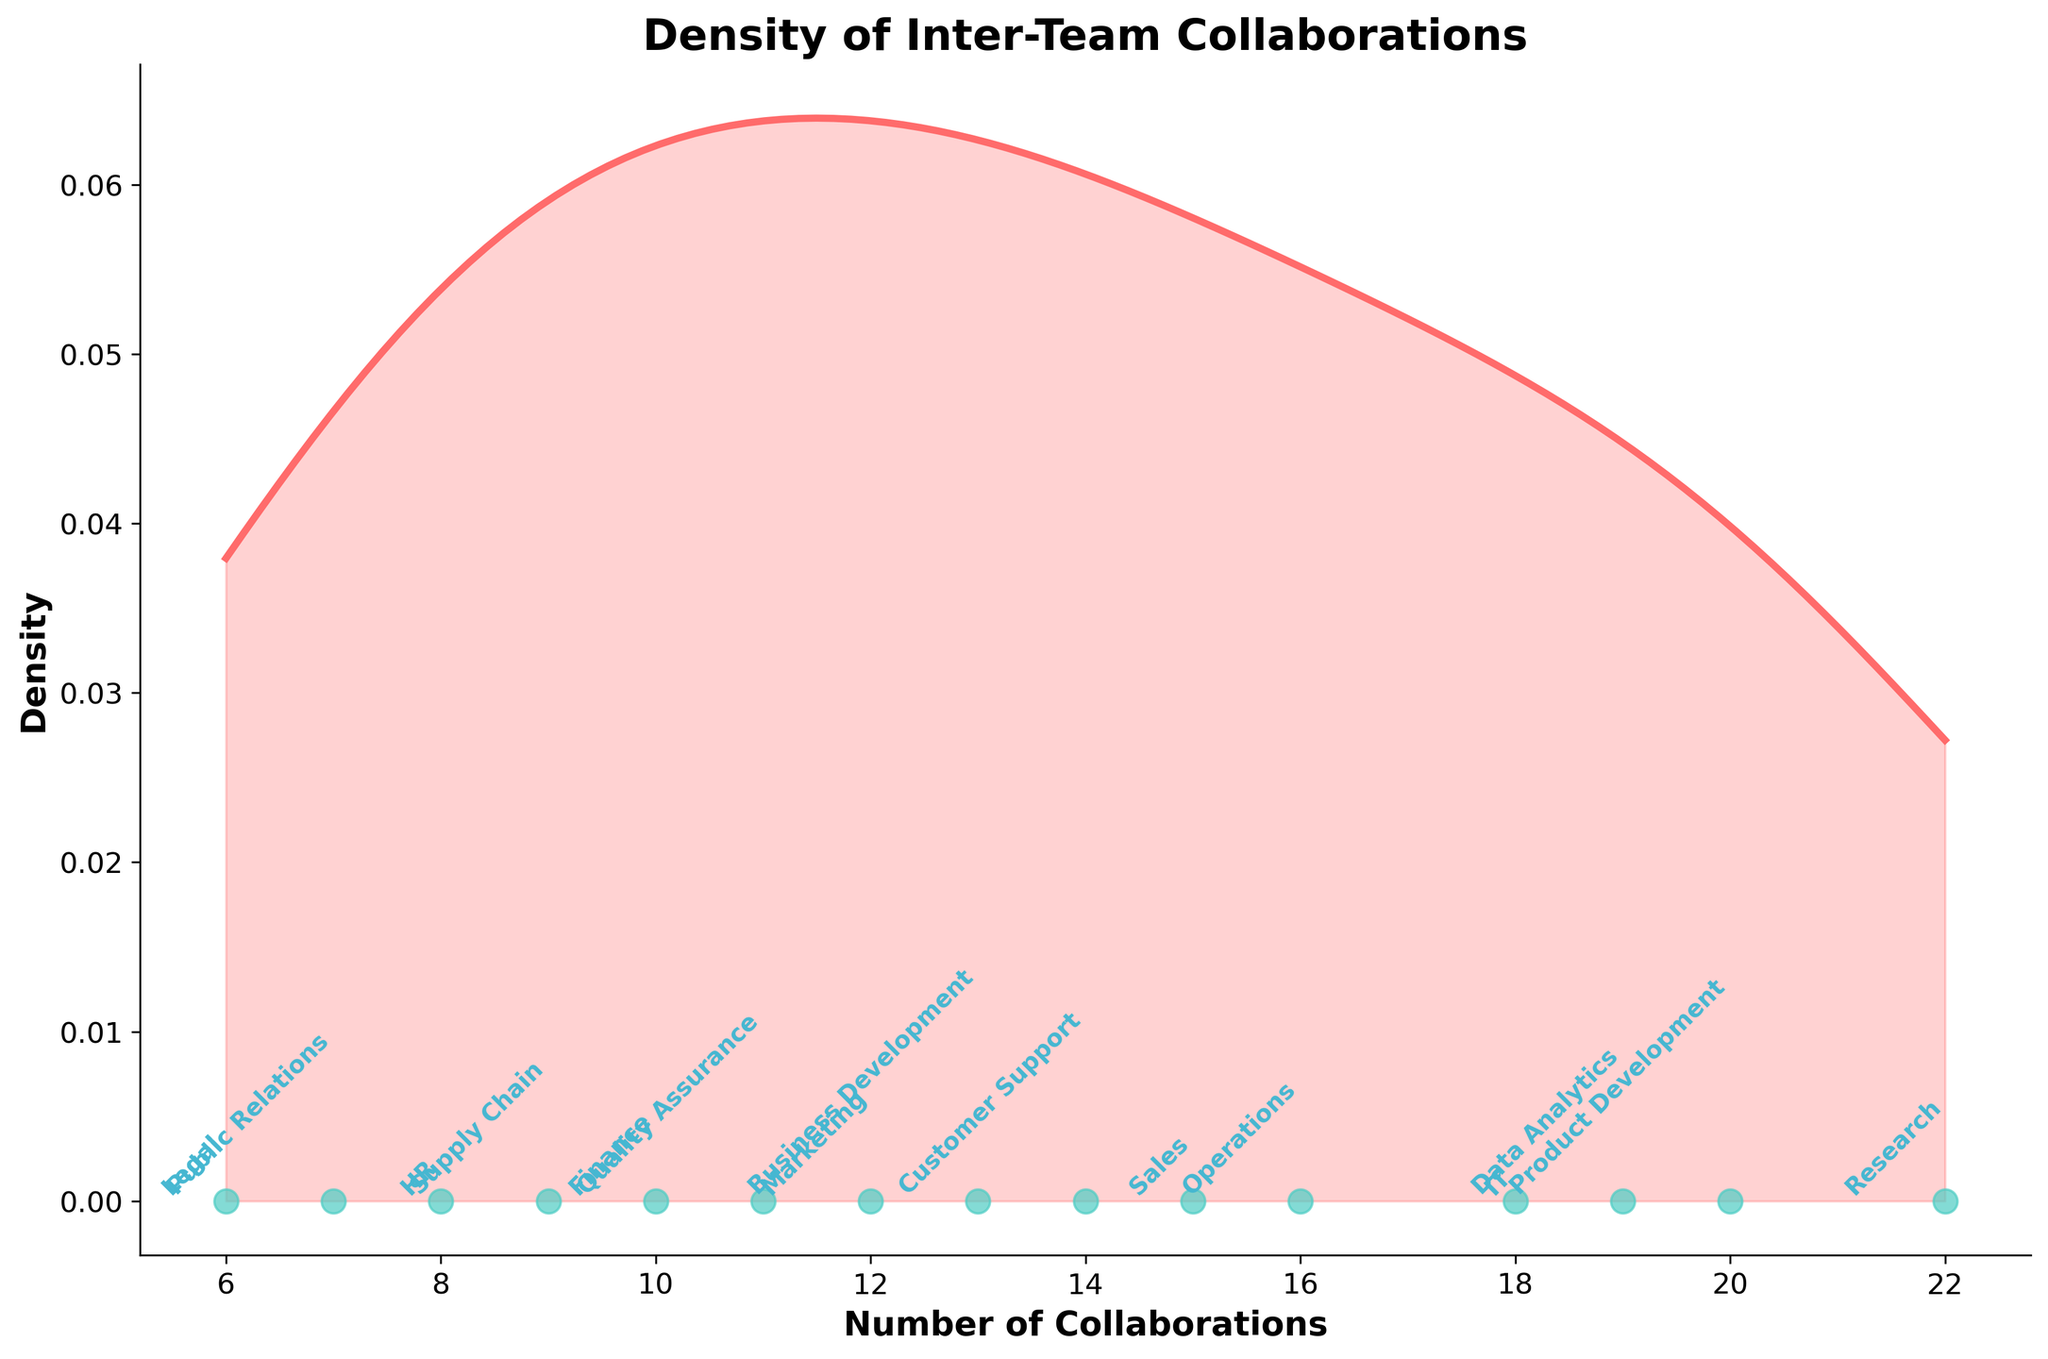How many teams have more than 15 collaborations per month? To answer this, observe the figure and identify the data points corresponding to collaborations greater than 15. Count the annotated team names at these points.
Answer: 5 Which team has the highest number of collaborations? Look at the figure and locate the highest point on the x-axis. Check the team name annotated at that point.
Answer: Research What is the median number of collaborations among the teams? The median value is the middle value when the data is ordered. Arrange the collaboration values and find the middle one. The sorted values are 6, 7, 8, 9, 10, 11, 12, 13, 14, 15, 16, 18, 19, 20, 22, so the median is the 8th value.
Answer: 13 Which team has the fewest collaborations per month? Find the lowest point on the x-axis and identify the annotated team name there.
Answer: Legal How many teams collaborate less than 10 times per month? Identify and count the data points below 10 on the x-axis, checking the corresponding team names.
Answer: 4 Compare the density of collaborations between "Marketing" and "Customer Support." Is the density higher for one? Look at the height of the density curve at the points corresponding to collaboration numbers for both Marketing (12) and Customer Support (14). Compare the values on the density curve.
Answer: Customer Support What is the average number of collaborations per team? Sum all collaboration values and divide by the number of teams (15): (12 + 15 + 18 + 8 + 10 + 20 + 14 + 6 + 16 + 22 + 13 + 11 + 9 + 7 + 19) / 15.
Answer: 13.2 How is density used in understanding the distribution of collaborations? Density in the plot represents the probability distribution of collaboration numbers. Higher density means more teams have collaboration numbers around that value.
Answer: It shows the probability distribution How does the number of collaborations in the Legal team compare to the median value? The Legal team's collaborations are 6. Compare this with the median value of 13.
Answer: Less 